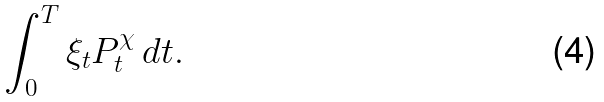<formula> <loc_0><loc_0><loc_500><loc_500>\int _ { 0 } ^ { T } \xi _ { t } P ^ { \chi } _ { t } \, d t .</formula> 